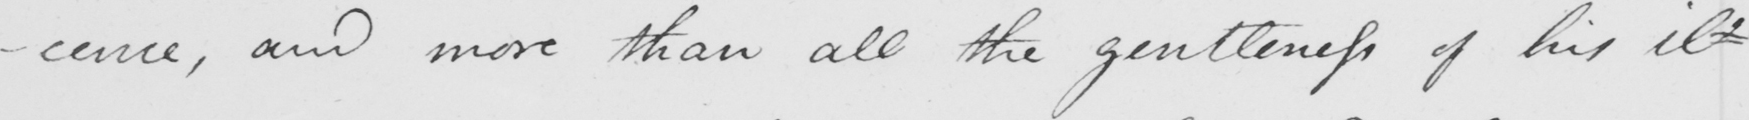Can you read and transcribe this handwriting? -cence , and more than all the gentleness of his il- 